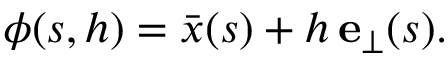<formula> <loc_0><loc_0><loc_500><loc_500>\boldsymbol \phi ( s , h ) = \bar { x } ( s ) + h \, e _ { \perp } ( s ) .</formula> 